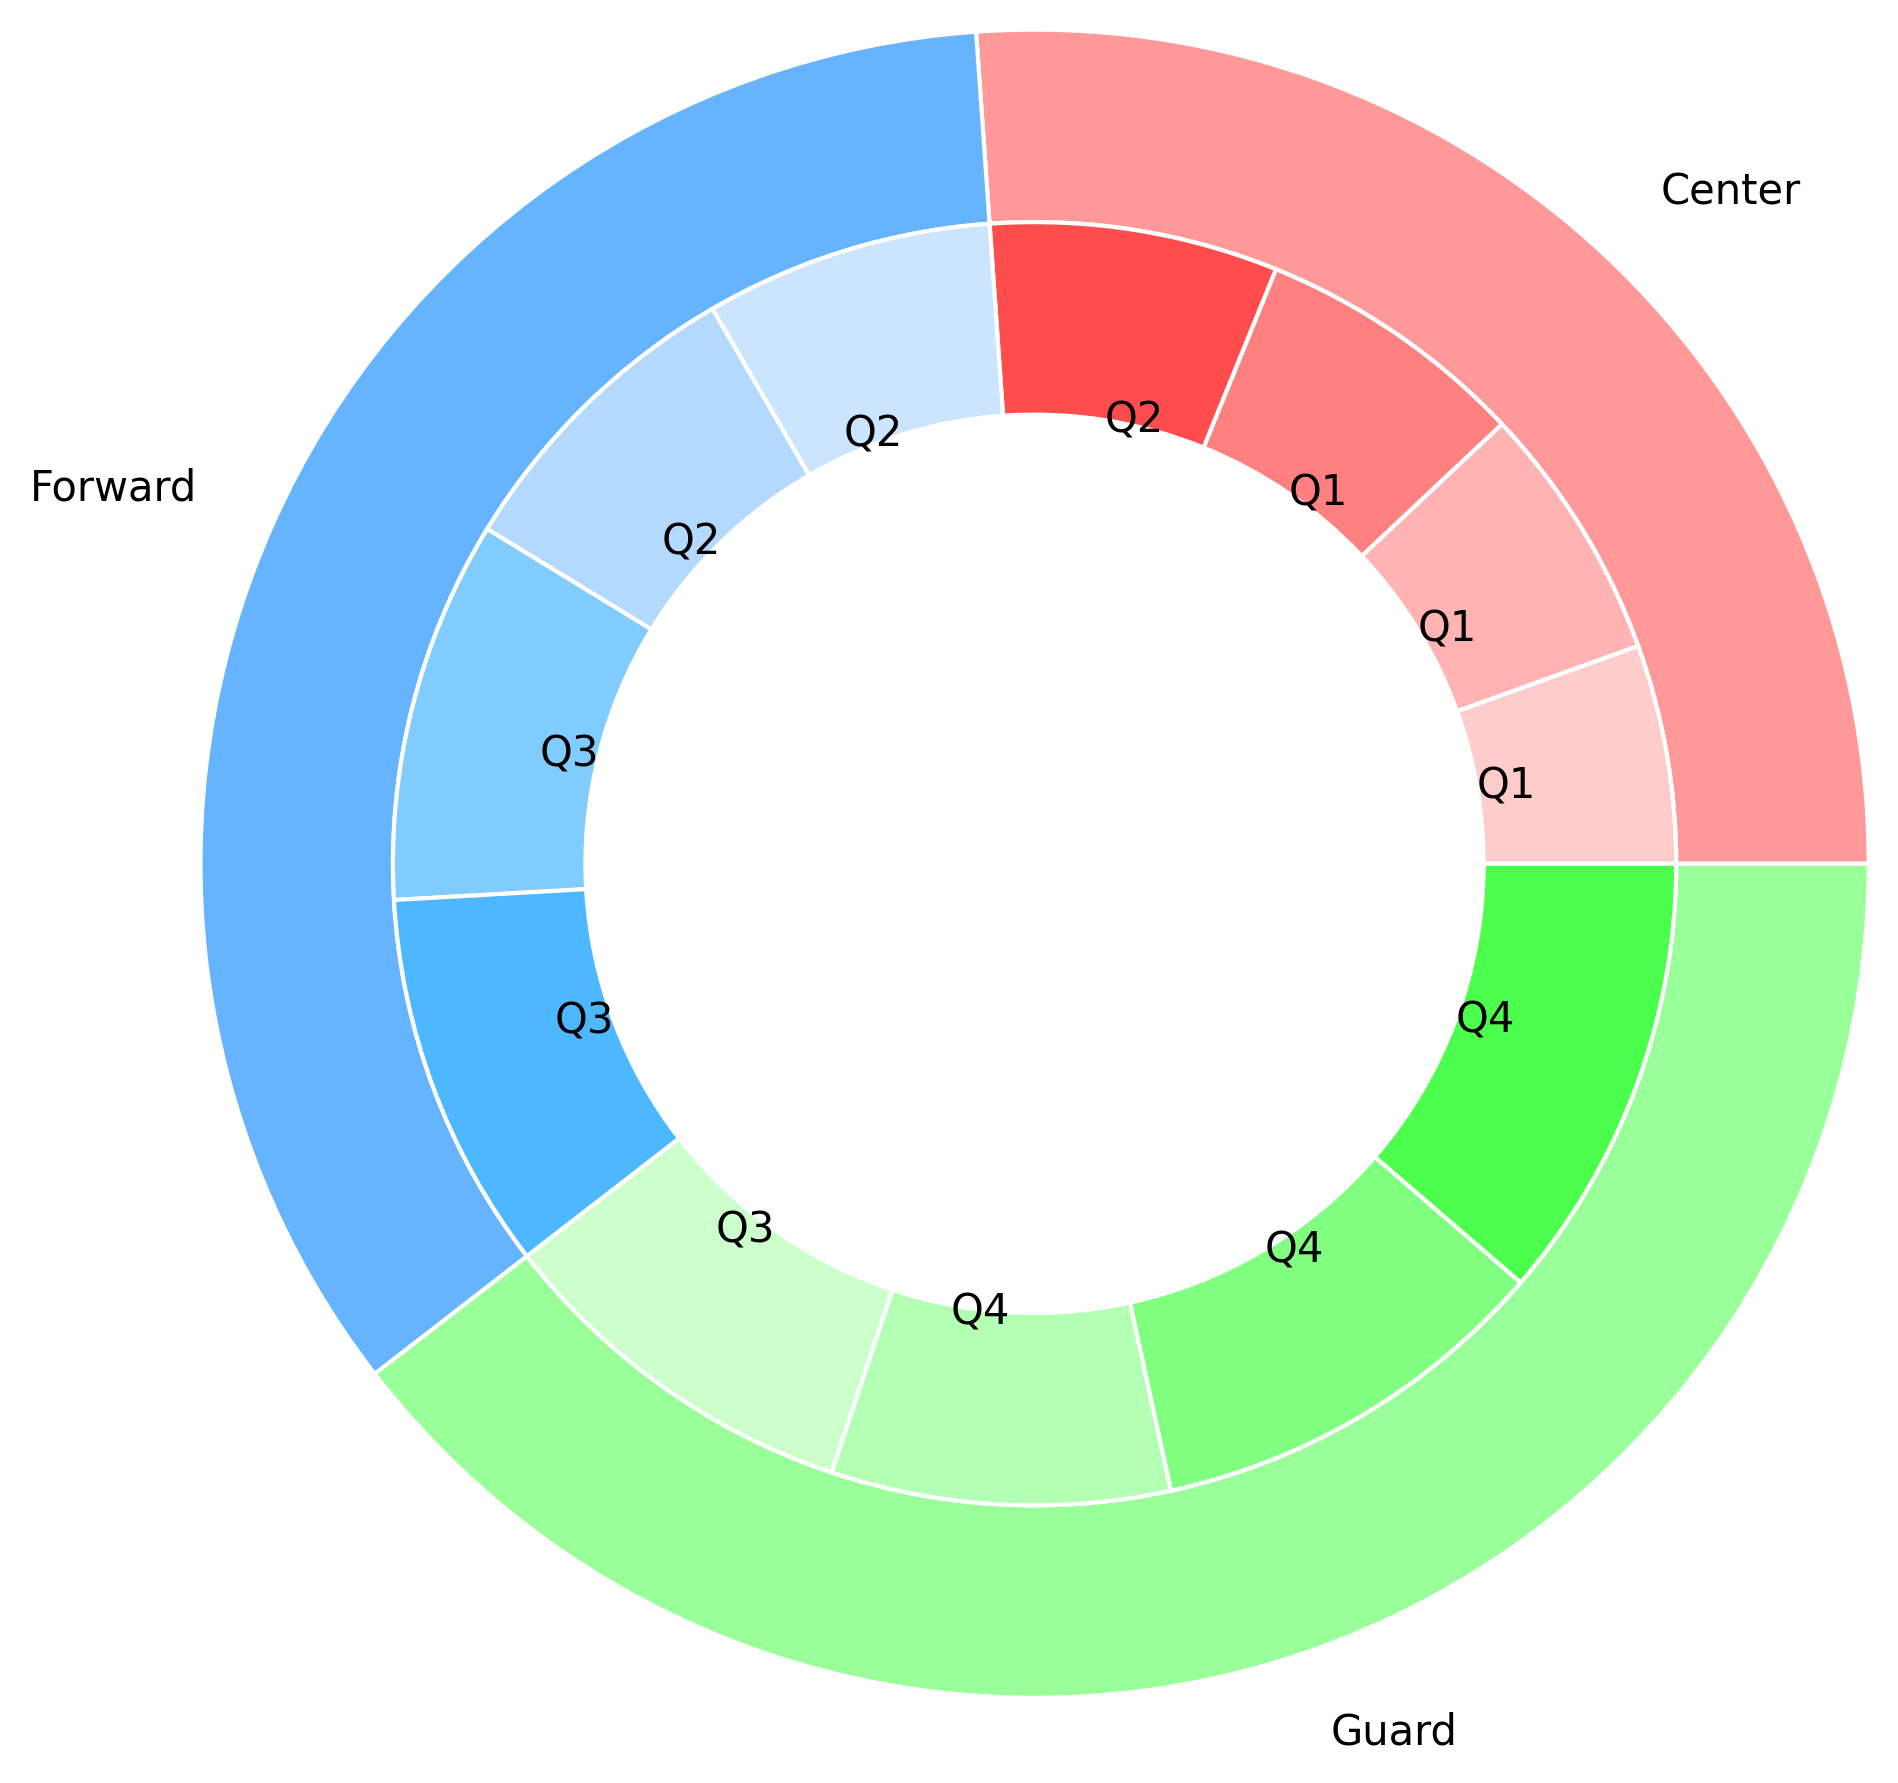Which player position scored the most points in total? Look at the outer ring to see which segment is largest. The Guard segment is the largest, indicating that Guards scored the most points in total.
Answer: Guards Which quarter did Centers score the least in? Look at the inner ring sections corresponding to Centers. The light green segment in Q1 is the smallest, indicating Q1 had the least points for Centers.
Answer: Q1 How do the total points scored by Guards compare to those scored by Forwards? Compare the size of the outer ring segments for Guards (red) and Forwards (blue). The Guards' segment is larger, which means Guards scored more points than Forwards.
Answer: Guards scored more Which quarter contributed the highest points for Forwards? Look at the blue segments in the inner ring that correspond to Forwards. The darkest blue segment (Q4) is the largest, indicating Q4 contributed the most points.
Answer: Q4 Are the total points scored by Centers in Q3 higher than those in Q2? Compare the green segments for Centers in Q3 and Q2 in the inner ring. The Q3 segment is slightly larger than the Q2 segment.
Answer: Yes, higher in Q3 What is the average number of points scored by Forwards in Q1 and Q2? For Forwards: Sum the points from Q1 and Q2 (60 + 66) and then divide by 2 to get the average. (60 + 66) / 2 = 63
Answer: 63 What proportion of the total points did Centers score in Q4 compared to Guards in Q4? Compare the green segment for Centers in Q4 with the red segment for Guards in Q4 in the inner ring. The segment for Guards in Q4 is much larger, indicating Centers scored a smaller proportion in Q4.
Answer: Lower proportion Which quarter shows the highest overall scoring from all positions combined? Find the largest combined segments within the inner ring for all three positions. The red segment for Guards in Q4 appears to be the largest, indicating this quarter had the highest overall scoring.
Answer: Q4 By how much do the total points scored by Guards in Q3 exceed those of Centers in Q3? Compare the inner ring segments for Guards and Centers in Q3, then subtract the smaller from the larger: 90 - 58 = 32 points.
Answer: 32 points Do Guards score more evenly across all quarters compared to Centers? Analyze the size difference of the inner ring segments for Guards (red) and Centers (green) across all quarters. The red segments are more uniform in size, indicating a more even scoring distribution.
Answer: Yes 